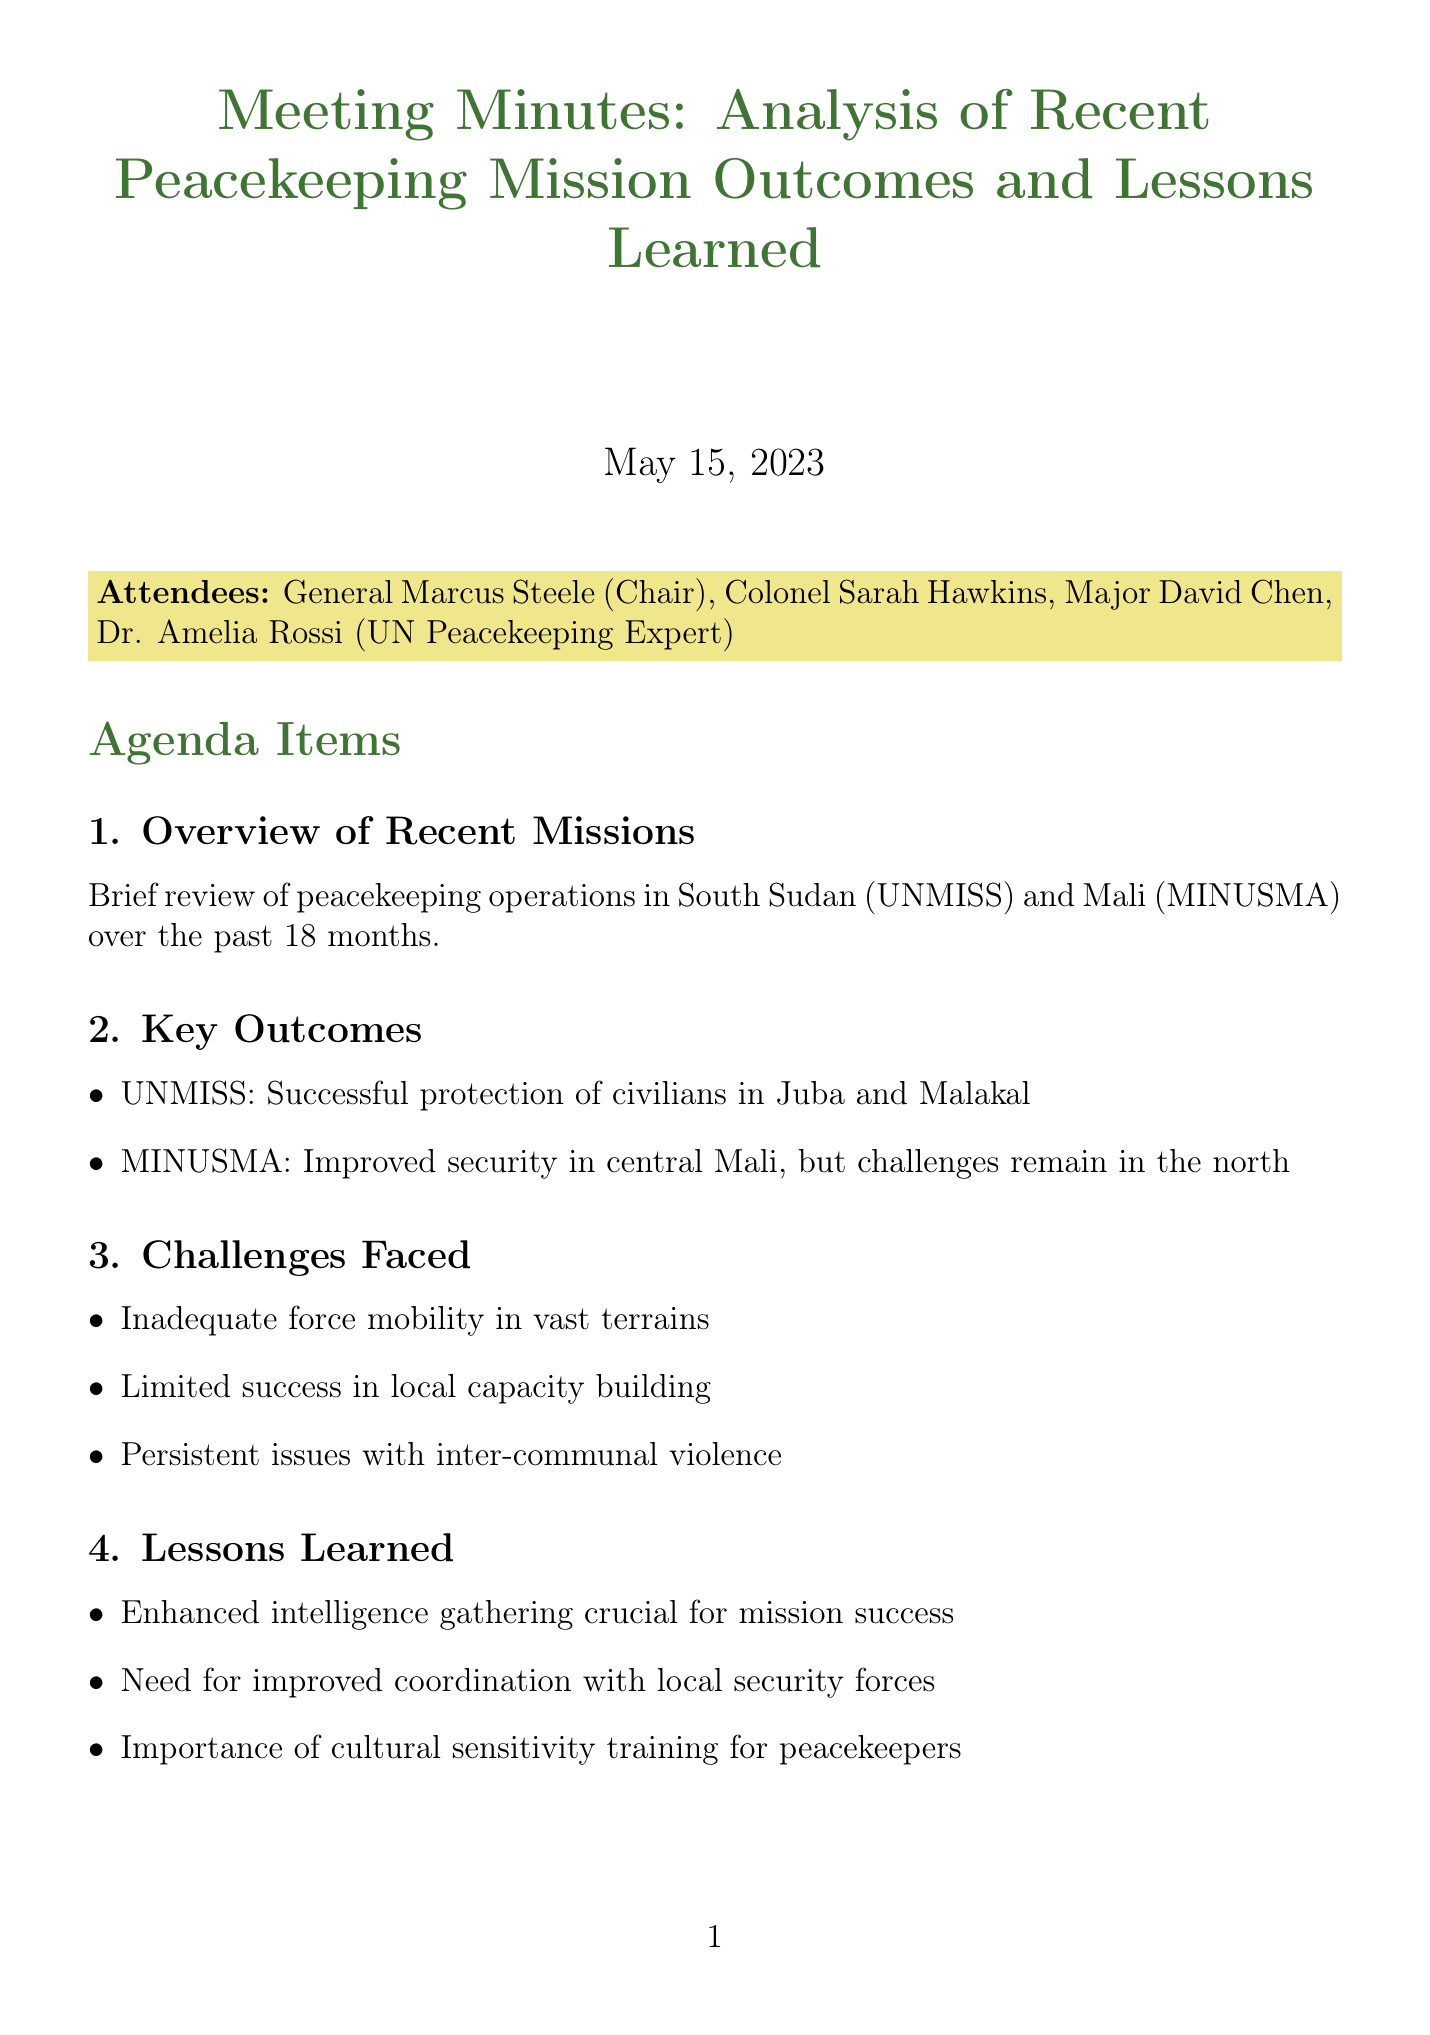what was the date of the meeting? The date of the meeting is stated clearly at the beginning of the document.
Answer: May 15, 2023 who chaired the meeting? The chairperson of the meeting is explicitly mentioned in the list of attendees.
Answer: General Marcus Steele what are the two missions reviewed in the meeting? The document lists the missions that were the focus of the review in the overview section.
Answer: UNMISS and MINUSMA what challenge is related to local capacity building? The challenges faced are listed in a bullet format, which includes information specific to local capacity building.
Answer: Limited success in local capacity building name one recommendation for future deployments. The recommendations section includes multiple suggestions for future actions.
Answer: Increase use of unmanned aerial vehicles (UAVs) for surveillance who is responsible for drafting revised SOPs? The action items section specifies who is assigned to complete each task.
Answer: Colonel Hawkins how many action items are listed? By counting the tasks in the action items section, the total number can be determined.
Answer: 2 what is one lesson learned mentioned in the meeting? The lessons learned are listed in a bullet format, which outlines key takeaways from the missions.
Answer: Enhanced intelligence gathering crucial for mission success what will be the next step after the meeting? The next steps section outlines what actions will be taken following the meeting.
Answer: Develop comprehensive training program incorporating lessons learned for upcoming mission in Central African Republic (MINUSCA) 